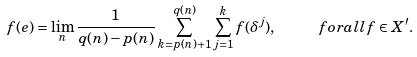Convert formula to latex. <formula><loc_0><loc_0><loc_500><loc_500>f ( e ) = \lim _ { n } \frac { 1 } { q ( n ) - p ( n ) } \sum _ { k = p ( n ) + 1 } ^ { q ( n ) } \sum _ { j = 1 } ^ { k } f ( \delta ^ { j } ) , \ \quad f o r a l l f \in X ^ { \prime } .</formula> 